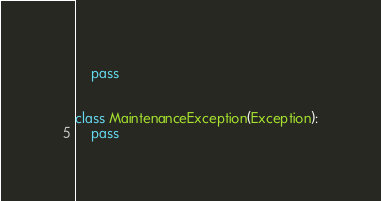Convert code to text. <code><loc_0><loc_0><loc_500><loc_500><_Python_>    pass


class MaintenanceException(Exception):
    pass
</code> 